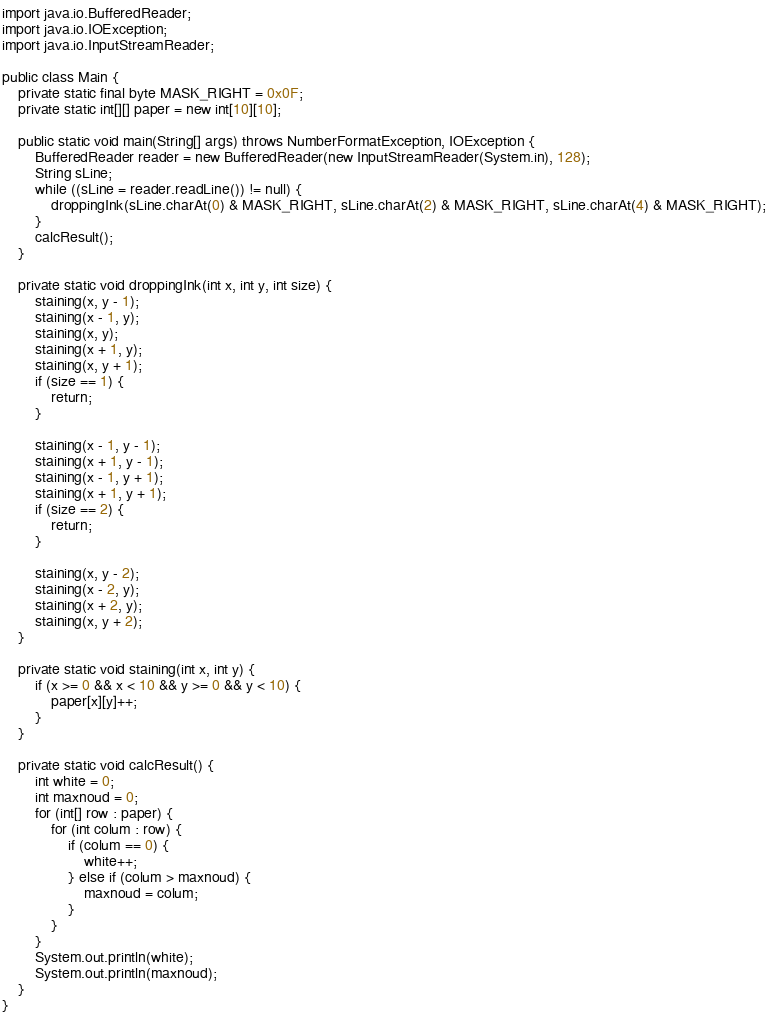Convert code to text. <code><loc_0><loc_0><loc_500><loc_500><_Java_>import java.io.BufferedReader;
import java.io.IOException;
import java.io.InputStreamReader;

public class Main {
	private static final byte MASK_RIGHT = 0x0F;
	private static int[][] paper = new int[10][10];

	public static void main(String[] args) throws NumberFormatException, IOException {
		BufferedReader reader = new BufferedReader(new InputStreamReader(System.in), 128);
		String sLine;
		while ((sLine = reader.readLine()) != null) {
			droppingInk(sLine.charAt(0) & MASK_RIGHT, sLine.charAt(2) & MASK_RIGHT, sLine.charAt(4) & MASK_RIGHT);
		}
		calcResult();
	}

	private static void droppingInk(int x, int y, int size) {
		staining(x, y - 1);
		staining(x - 1, y);
		staining(x, y);
		staining(x + 1, y);
		staining(x, y + 1);
		if (size == 1) {
			return;
		}

		staining(x - 1, y - 1);
		staining(x + 1, y - 1);
		staining(x - 1, y + 1);
		staining(x + 1, y + 1);
		if (size == 2) {
			return;
		}

		staining(x, y - 2);
		staining(x - 2, y);
		staining(x + 2, y);
		staining(x, y + 2);
	}

	private static void staining(int x, int y) {
		if (x >= 0 && x < 10 && y >= 0 && y < 10) {
			paper[x][y]++;
		}
	}

	private static void calcResult() {
		int white = 0;
		int maxnoud = 0;
		for (int[] row : paper) {
			for (int colum : row) {
				if (colum == 0) {
					white++;
				} else if (colum > maxnoud) {
					maxnoud = colum;
				}
			}
		}
		System.out.println(white);
		System.out.println(maxnoud);
	}
}</code> 